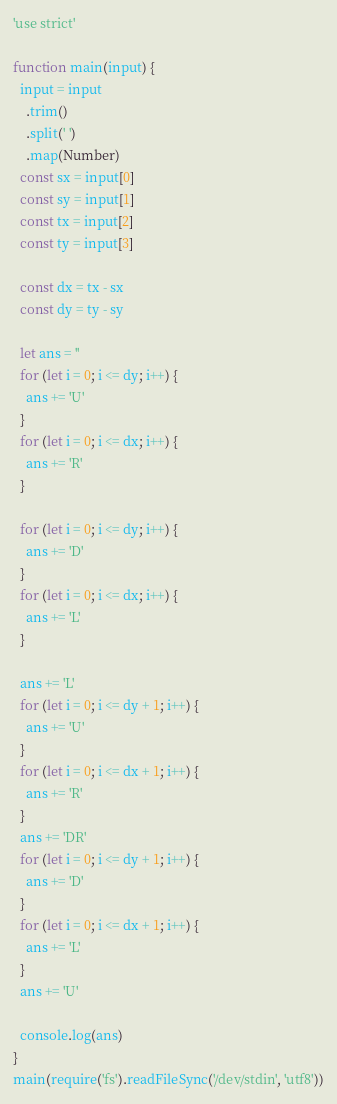Convert code to text. <code><loc_0><loc_0><loc_500><loc_500><_JavaScript_>'use strict'

function main(input) {
  input = input
    .trim()
    .split(' ')
    .map(Number)
  const sx = input[0]
  const sy = input[1]
  const tx = input[2]
  const ty = input[3]

  const dx = tx - sx
  const dy = ty - sy

  let ans = ''
  for (let i = 0; i <= dy; i++) {
    ans += 'U'
  }
  for (let i = 0; i <= dx; i++) {
    ans += 'R'
  }

  for (let i = 0; i <= dy; i++) {
    ans += 'D'
  }
  for (let i = 0; i <= dx; i++) {
    ans += 'L'
  }

  ans += 'L'
  for (let i = 0; i <= dy + 1; i++) {
    ans += 'U'
  }
  for (let i = 0; i <= dx + 1; i++) {
    ans += 'R'
  }
  ans += 'DR'
  for (let i = 0; i <= dy + 1; i++) {
    ans += 'D'
  }
  for (let i = 0; i <= dx + 1; i++) {
    ans += 'L'
  }
  ans += 'U'

  console.log(ans)
}
main(require('fs').readFileSync('/dev/stdin', 'utf8'))
</code> 